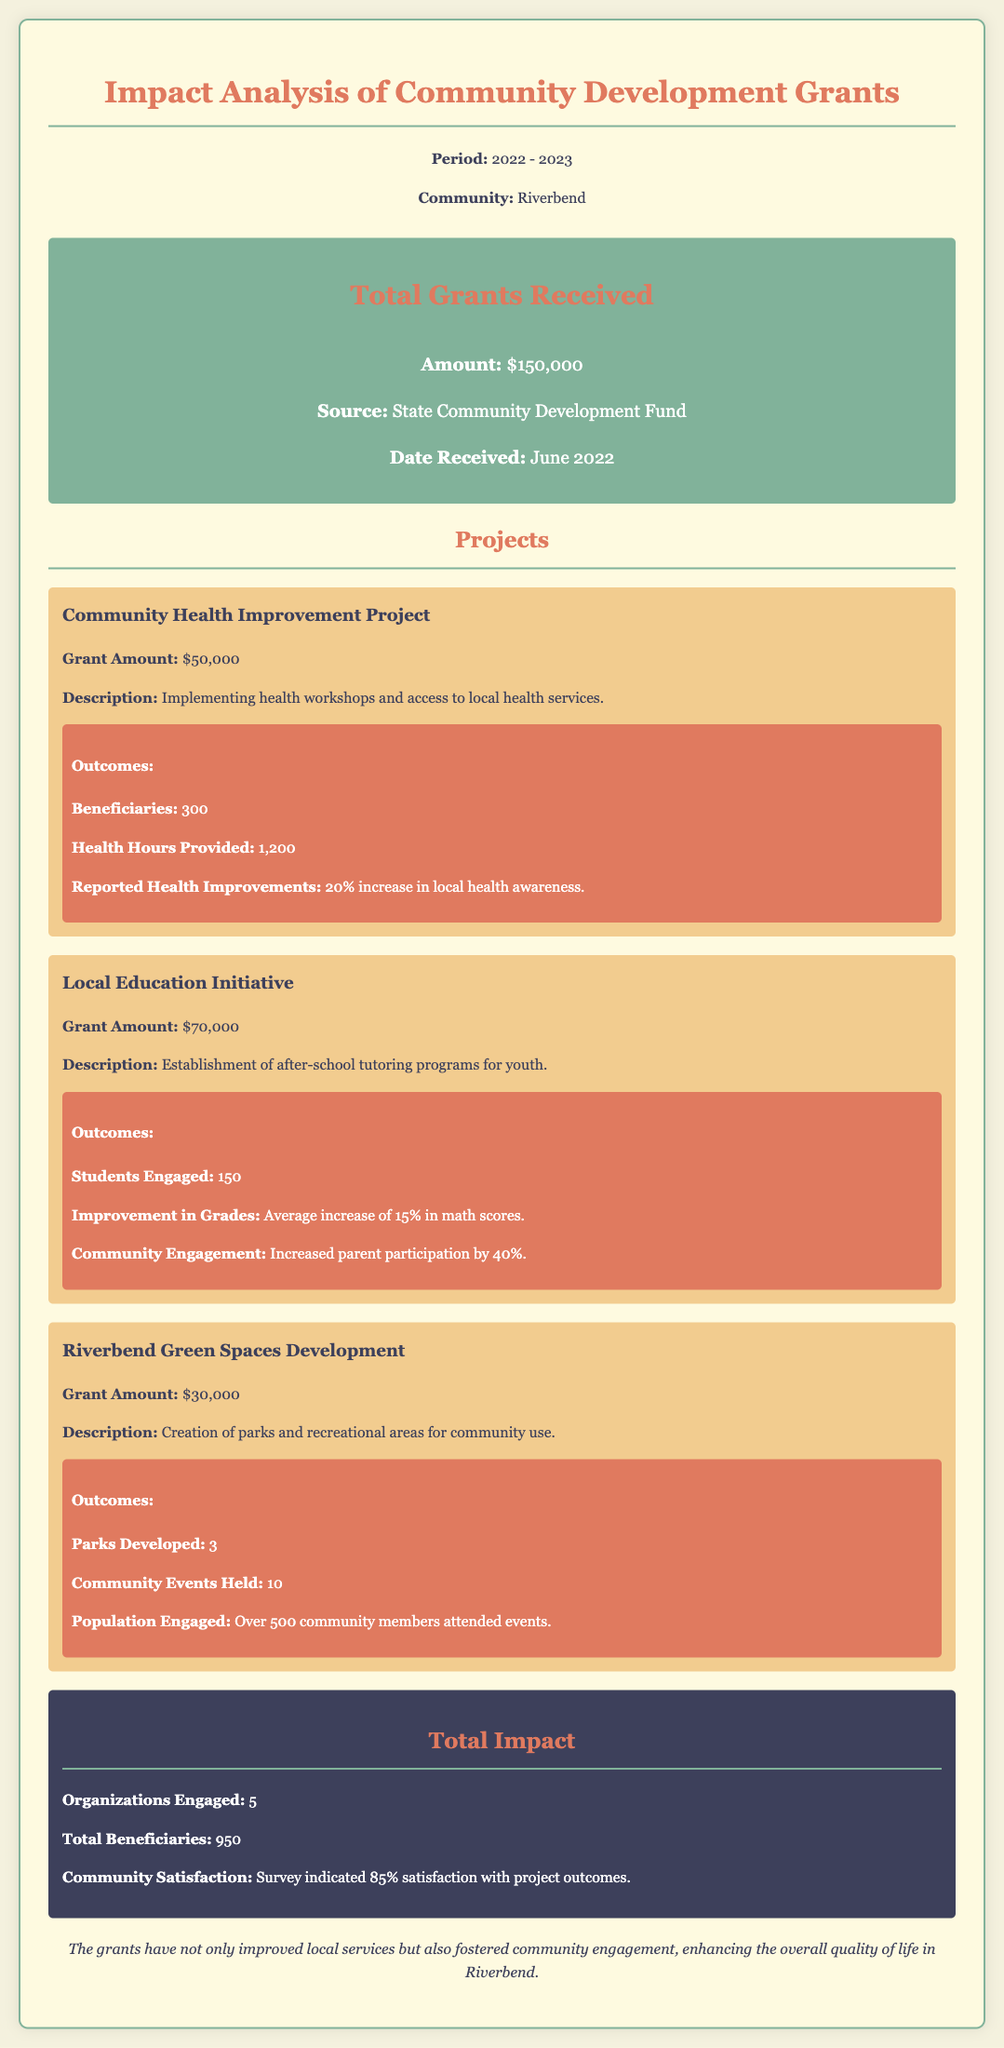what is the total amount of grants received? The total amount of grants received is stated in the document under the total grants section.
Answer: $150,000 what is the grant amount for the Community Health Improvement Project? The grant amount is specified in the project description for the Community Health Improvement Project.
Answer: $50,000 how many parks were developed in the Riverbend Green Spaces Development project? The number of parks developed is mentioned in the outcomes section of the Riverbend Green Spaces Development project.
Answer: 3 what percentage of community satisfaction was reported? The percentage of community satisfaction can be found in the total impact section of the report.
Answer: 85% what was the average improvement in math scores for the Local Education Initiative? The average improvement in math scores is listed under the outcomes for the Local Education Initiative project.
Answer: 15% how many beneficiaries were reported in total across all projects? The total number of beneficiaries is provided in the total impact section of the report.
Answer: 950 what is the source of the grants received? The source of the grants is noted in the total grants section of the document.
Answer: State Community Development Fund how many community members attended events related to the Riverbend Green Spaces project? The number of community members who attended events is listed in the outcomes section of the Riverbend Green Spaces Development project.
Answer: Over 500 community members 